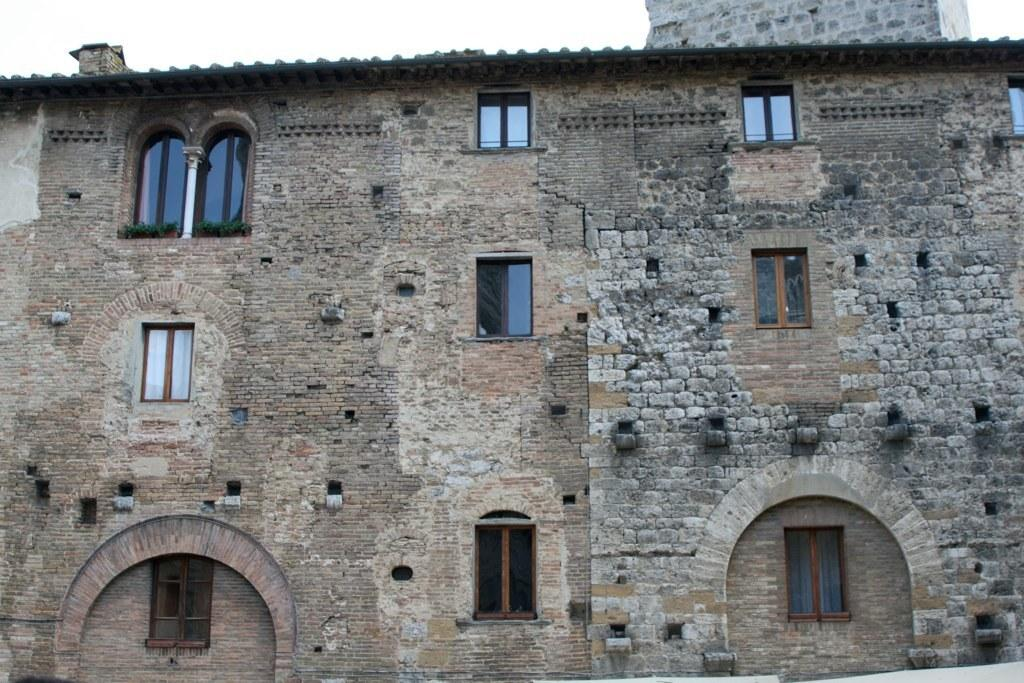What type of structure is present in the image? There is a building in the image. What feature can be seen on the building? The building has windows. What can be seen in the background of the image? The sky is visible in the image. What is located at the top of the building? There is an object at the top of the building. How many eyes can be seen on the building in the image? There are no eyes visible on the building in the image. Is there a monkey climbing the building in the image? There is no monkey present in the image. 